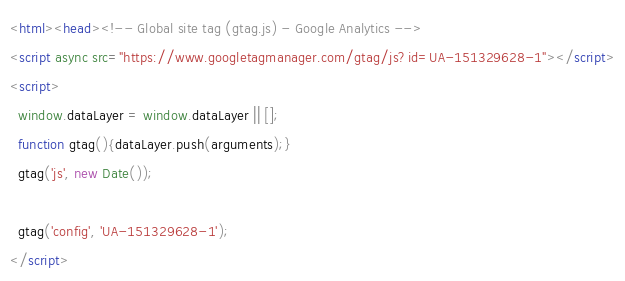<code> <loc_0><loc_0><loc_500><loc_500><_HTML_><html><head><!-- Global site tag (gtag.js) - Google Analytics -->
<script async src="https://www.googletagmanager.com/gtag/js?id=UA-151329628-1"></script>
<script>
  window.dataLayer = window.dataLayer || [];
  function gtag(){dataLayer.push(arguments);}
  gtag('js', new Date());

  gtag('config', 'UA-151329628-1');
</script></code> 